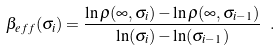<formula> <loc_0><loc_0><loc_500><loc_500>\beta _ { e f f } ( \sigma _ { i } ) = \frac { \ln \rho ( \infty , \sigma _ { i } ) - \ln \rho ( \infty , \sigma _ { i - 1 } ) } { \ln ( \sigma _ { i } ) - \ln ( \sigma _ { i - 1 } ) } \ .</formula> 